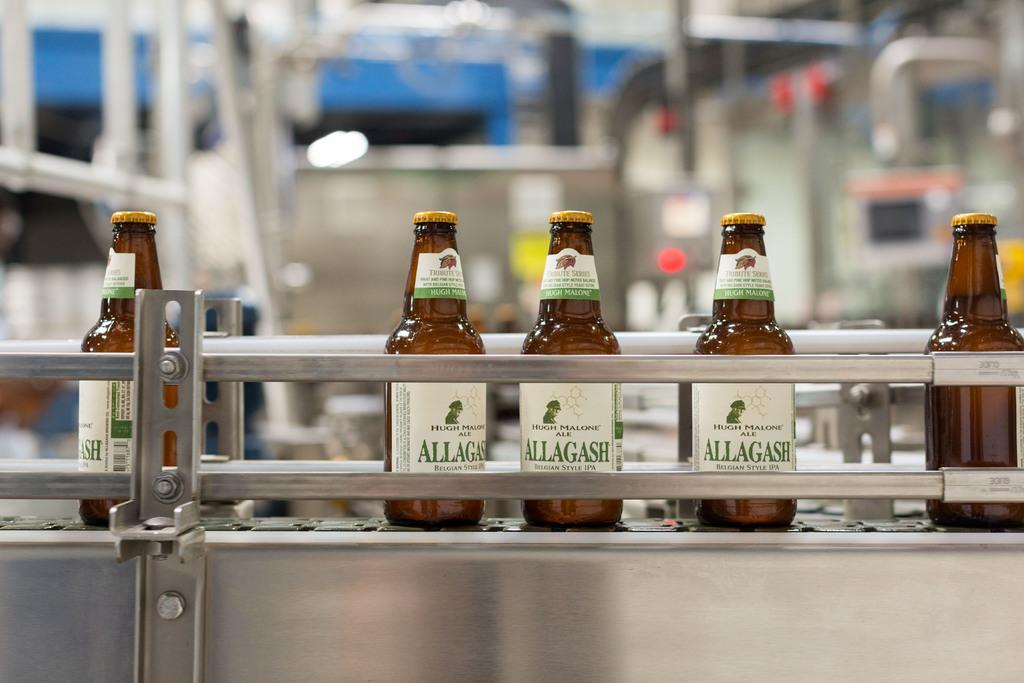<image>
Render a clear and concise summary of the photo. Bottles of Allagash alcohol on top of a table. 